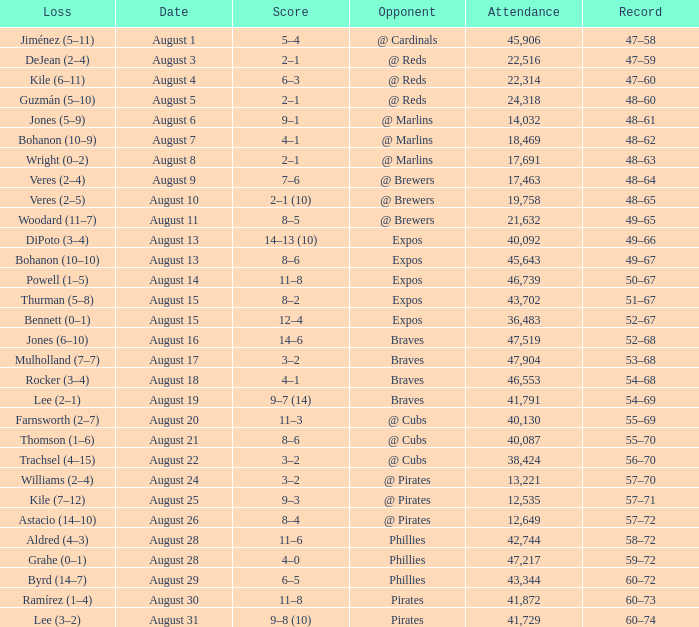What is the lowest attendance total on August 26? 12649.0. 